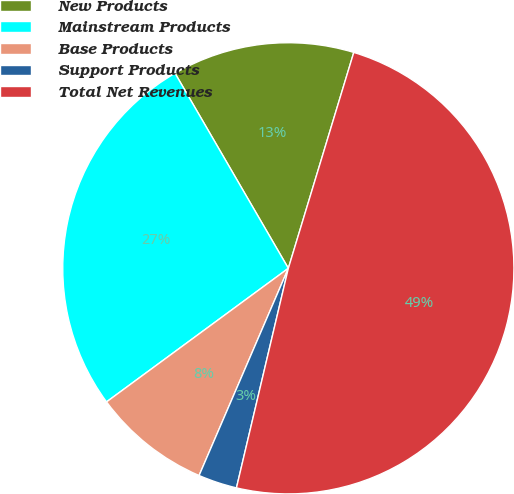Convert chart. <chart><loc_0><loc_0><loc_500><loc_500><pie_chart><fcel>New Products<fcel>Mainstream Products<fcel>Base Products<fcel>Support Products<fcel>Total Net Revenues<nl><fcel>13.06%<fcel>26.71%<fcel>8.44%<fcel>2.78%<fcel>49.01%<nl></chart> 